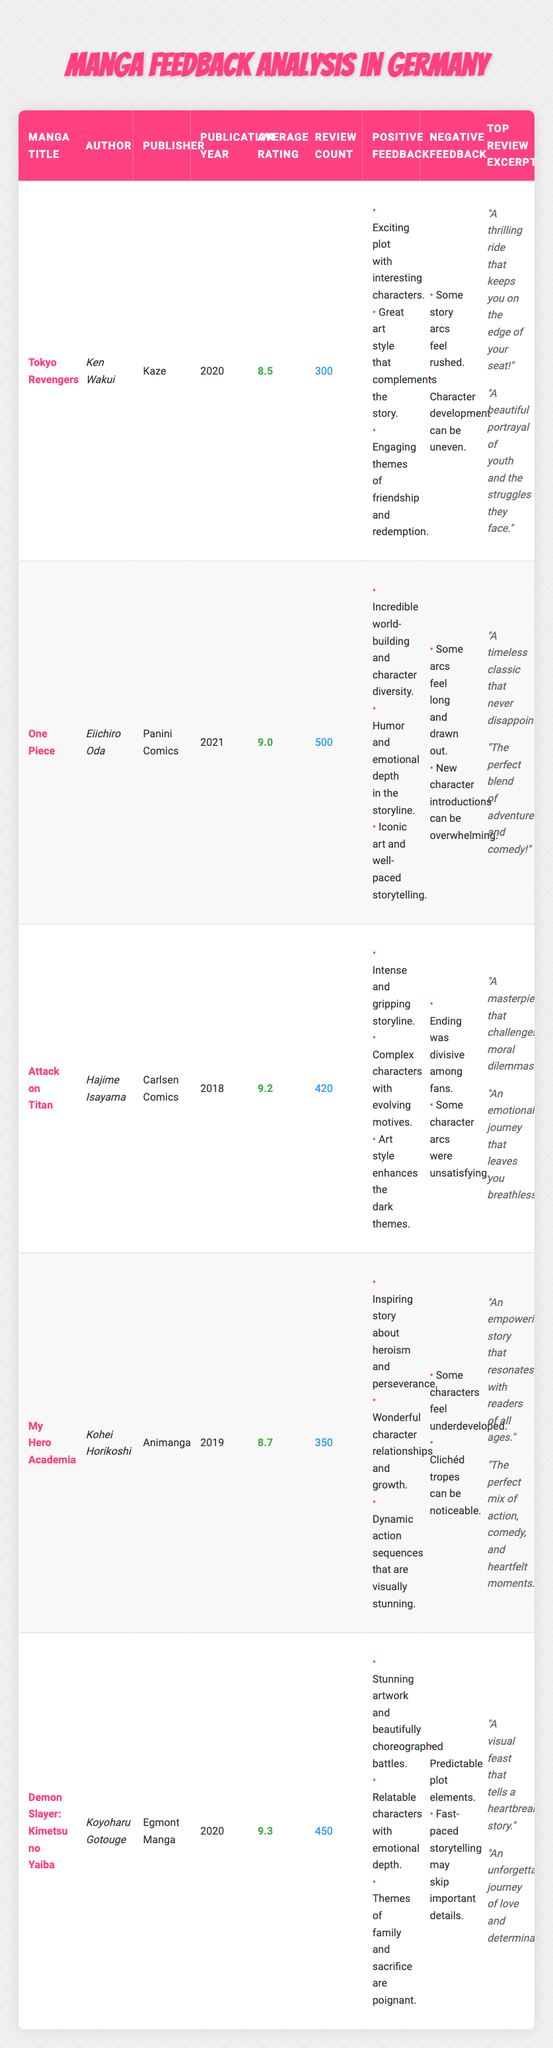What is the average rating of *Demon Slayer: Kimetsu no Yaiba*? The table shows that the average rating for *Demon Slayer: Kimetsu no Yaiba* is listed as 9.3.
Answer: 9.3 Which manga has the highest review count? By comparing the review counts listed in the table, *One Piece* has the highest with 500 reviews.
Answer: *One Piece* What year was *Attack on Titan* published? The table indicates that *Attack on Titan* was published in 2018.
Answer: 2018 How many positive feedback comments does *My Hero Academia* have? Referencing the table, *My Hero Academia* has three positive feedback comments listed.
Answer: 3 What is the difference in average ratings between *Demon Slayer: Kimetsu no Yaiba* and *Tokyo Revengers*? The average rating for *Demon Slayer: Kimetsu no Yaiba* is 9.3 and for *Tokyo Revengers* is 8.5. The difference is 9.3 - 8.5 = 0.8.
Answer: 0.8 Is there any negative feedback for *One Piece*? Yes, the table lists two negative feedback comments for *One Piece*, confirming that it has negative feedback.
Answer: Yes What are the top two review excerpts for *Tokyo Revengers*? The table shows the top review excerpts for *Tokyo Revengers* are: "A thrilling ride that keeps you on the edge of your seat!" and "A beautiful portrayal of youth and the struggles they face."
Answer: "A thrilling ride that keeps you on the edge of your seat!" and "A beautiful portrayal of youth and the struggles they face." Which manga has the lowest average rating and what is that rating? Checking the average ratings, *Tokyo Revengers* has the lowest at 8.5.
Answer: 8.5 Calculate the total number of reviews for all manga titles listed in the table. Adding the review counts: 300 (Tokyo Revengers) + 500 (One Piece) + 420 (Attack on Titan) + 350 (My Hero Academia) + 450 (Demon Slayer) = 2020 total reviews.
Answer: 2020 Are the themes of family and sacrifice mentioned in the positive feedback for any manga? Yes, the positive feedback for *Demon Slayer: Kimetsu no Yaiba* mentions themes of family and sacrifice.
Answer: Yes 